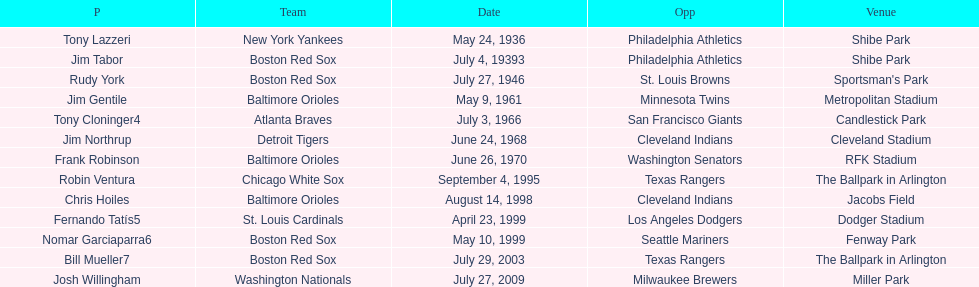What was the name of the last person to accomplish this up to date? Josh Willingham. 